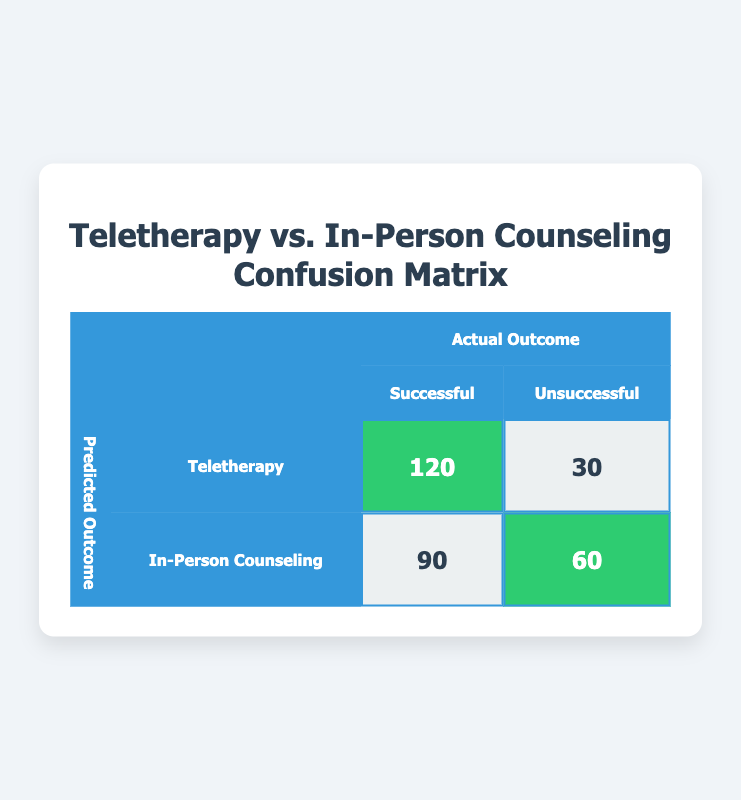What is the total number of individuals who participated in teletherapy? The total number of individuals who participated in teletherapy can be found by adding the number of successful and unsuccessful outcomes: 120 (successful) + 30 (unsuccessful) = 150.
Answer: 150 How many individuals were successful in in-person counseling? Looking at the table, the successful count for in-person counseling is explicitly stated as 90.
Answer: 90 What is the total number of unsuccessful outcomes across both counseling types? To find the total unsuccessful outcomes, we add the unsuccessful outcomes for both teletherapy and in-person counseling: 30 (teletherapy) + 60 (in-person counseling) = 90.
Answer: 90 Which type of counseling had a higher success rate? We calculate the success rates for both counseling types. Teletherapy's success rate is 120/(120 + 30) = 120/150 = 0.8 or 80%. In-person counseling's success rate is 90/(90 + 60) = 90/150 = 0.6 or 60%. Therefore, teletherapy had a higher success rate.
Answer: Teletherapy Is the number of successful outcomes in teletherapy greater than that in in-person counseling? Yes. The number of successful outcomes for teletherapy is 120, and for in-person counseling, it is 90. Thus, 120 is indeed greater than 90.
Answer: Yes What is the difference in successful outcomes between teletherapy and in-person counseling? To find the difference in successful outcomes, subtract the successful count of in-person counseling from that of teletherapy: 120 (teletherapy) - 90 (in-person counseling) = 30.
Answer: 30 What percentage of total teletherapy outcomes were unsuccessful? First, we find the total outcomes for teletherapy: 150. Unsuccessful outcomes are 30. The percentage is calculated as (30/150) * 100 = 20%.
Answer: 20% Explain how many more unsuccessful outcomes there are in in-person counseling compared to teletherapy. First, we identify the number of unsuccessful outcomes: in-person counseling has 60, while teletherapy has 30. To find the difference, we subtract the teletherapy number from the in-person number: 60 - 30 = 30. Therefore, there are 30 more unsuccessful outcomes in in-person counseling compared to teletherapy.
Answer: 30 What is the total success rate for teletherapy and in-person counseling combined? First, we find the total successful outcomes across both types: 120 (teletherapy) + 90 (in-person) = 210 successful outcomes. Then, we calculate the total number of individuals who participated: 150 (teletherapy) + 150 (in-person) = 300 participants. The total success rate is thus 210/300 = 0.7 or 70%.
Answer: 70 